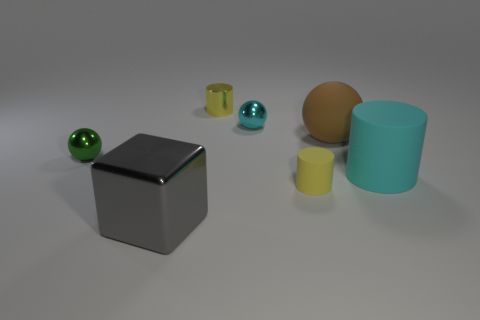How would you explain the lighting in this scene? The lighting in the scene looks soft and diffused, likely from an overhead source, given the soft shadows directly beneath the objects. There is no harsh direct light, which creates a calm, evenly illuminated arrangement. This type of lighting minimizes glare and allows for the colors and textures of the objects to be seen clearly. 